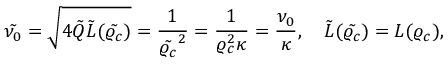Convert formula to latex. <formula><loc_0><loc_0><loc_500><loc_500>\tilde { \nu _ { 0 } } = \sqrt { 4 \tilde { Q } \tilde { L } ( \tilde { \varrho _ { c } } ) } = \frac { 1 } { \tilde { \varrho _ { c } } ^ { 2 } } = \frac { 1 } { \varrho _ { c } ^ { 2 } \kappa } = \frac { \nu _ { 0 } } { \kappa } , \quad \tilde { L } ( \tilde { \varrho _ { c } } ) = L ( \varrho _ { c } ) ,</formula> 